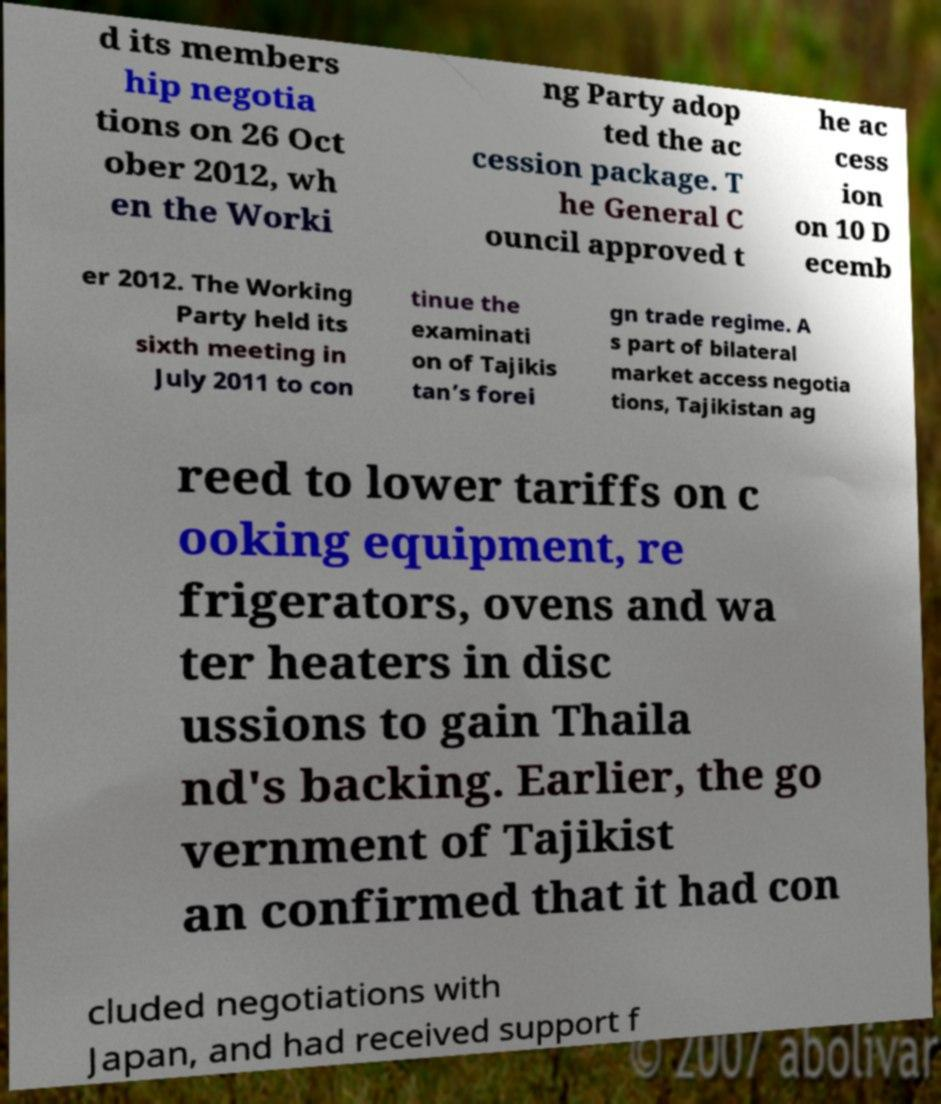Please identify and transcribe the text found in this image. d its members hip negotia tions on 26 Oct ober 2012, wh en the Worki ng Party adop ted the ac cession package. T he General C ouncil approved t he ac cess ion on 10 D ecemb er 2012. The Working Party held its sixth meeting in July 2011 to con tinue the examinati on of Tajikis tan’s forei gn trade regime. A s part of bilateral market access negotia tions, Tajikistan ag reed to lower tariffs on c ooking equipment, re frigerators, ovens and wa ter heaters in disc ussions to gain Thaila nd's backing. Earlier, the go vernment of Tajikist an confirmed that it had con cluded negotiations with Japan, and had received support f 